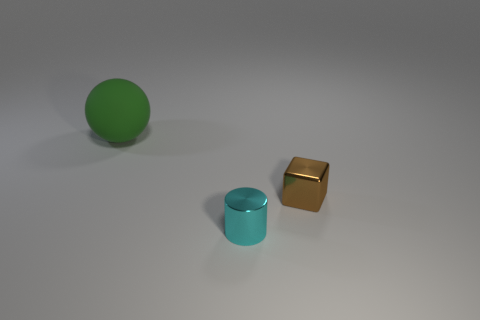Add 3 big green objects. How many objects exist? 6 Subtract all blocks. How many objects are left? 2 Subtract all large red cylinders. Subtract all small objects. How many objects are left? 1 Add 2 large green rubber spheres. How many large green rubber spheres are left? 3 Add 1 big gray blocks. How many big gray blocks exist? 1 Subtract 1 cyan cylinders. How many objects are left? 2 Subtract 1 cylinders. How many cylinders are left? 0 Subtract all brown spheres. Subtract all blue cylinders. How many spheres are left? 1 Subtract all purple spheres. How many gray blocks are left? 0 